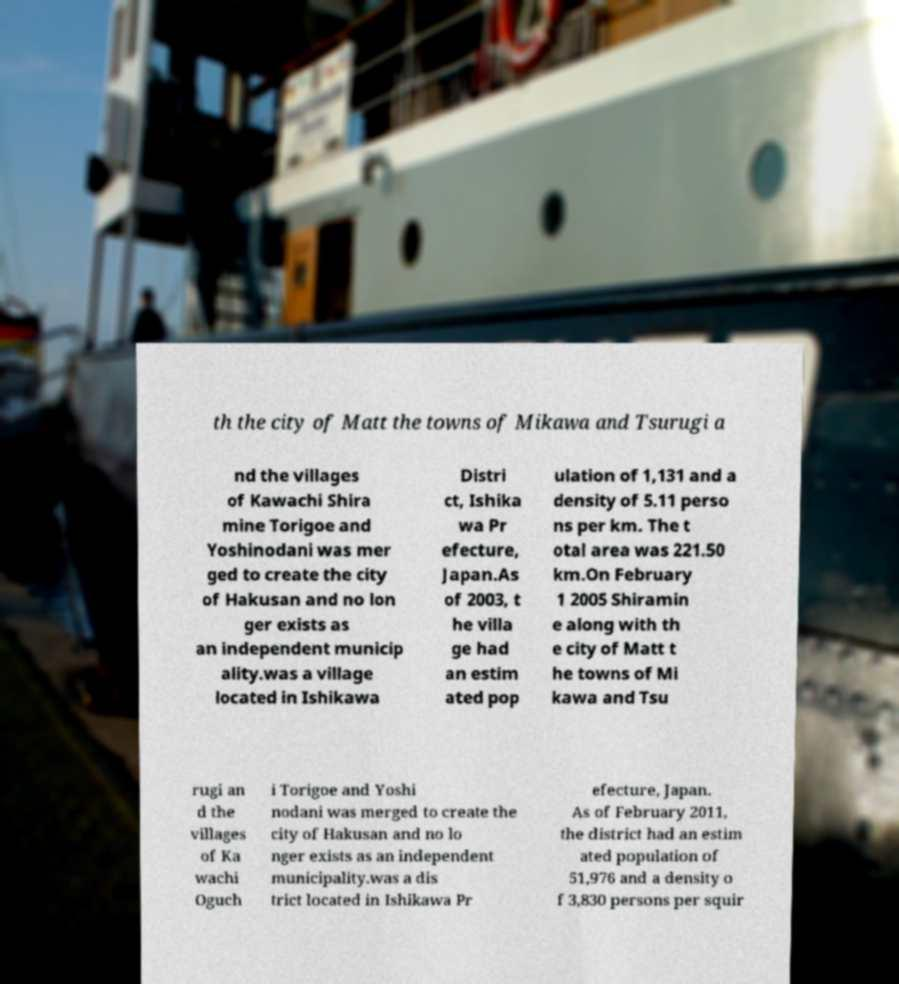Can you read and provide the text displayed in the image?This photo seems to have some interesting text. Can you extract and type it out for me? th the city of Matt the towns of Mikawa and Tsurugi a nd the villages of Kawachi Shira mine Torigoe and Yoshinodani was mer ged to create the city of Hakusan and no lon ger exists as an independent municip ality.was a village located in Ishikawa Distri ct, Ishika wa Pr efecture, Japan.As of 2003, t he villa ge had an estim ated pop ulation of 1,131 and a density of 5.11 perso ns per km. The t otal area was 221.50 km.On February 1 2005 Shiramin e along with th e city of Matt t he towns of Mi kawa and Tsu rugi an d the villages of Ka wachi Oguch i Torigoe and Yoshi nodani was merged to create the city of Hakusan and no lo nger exists as an independent municipality.was a dis trict located in Ishikawa Pr efecture, Japan. As of February 2011, the district had an estim ated population of 51,976 and a density o f 3,830 persons per squir 